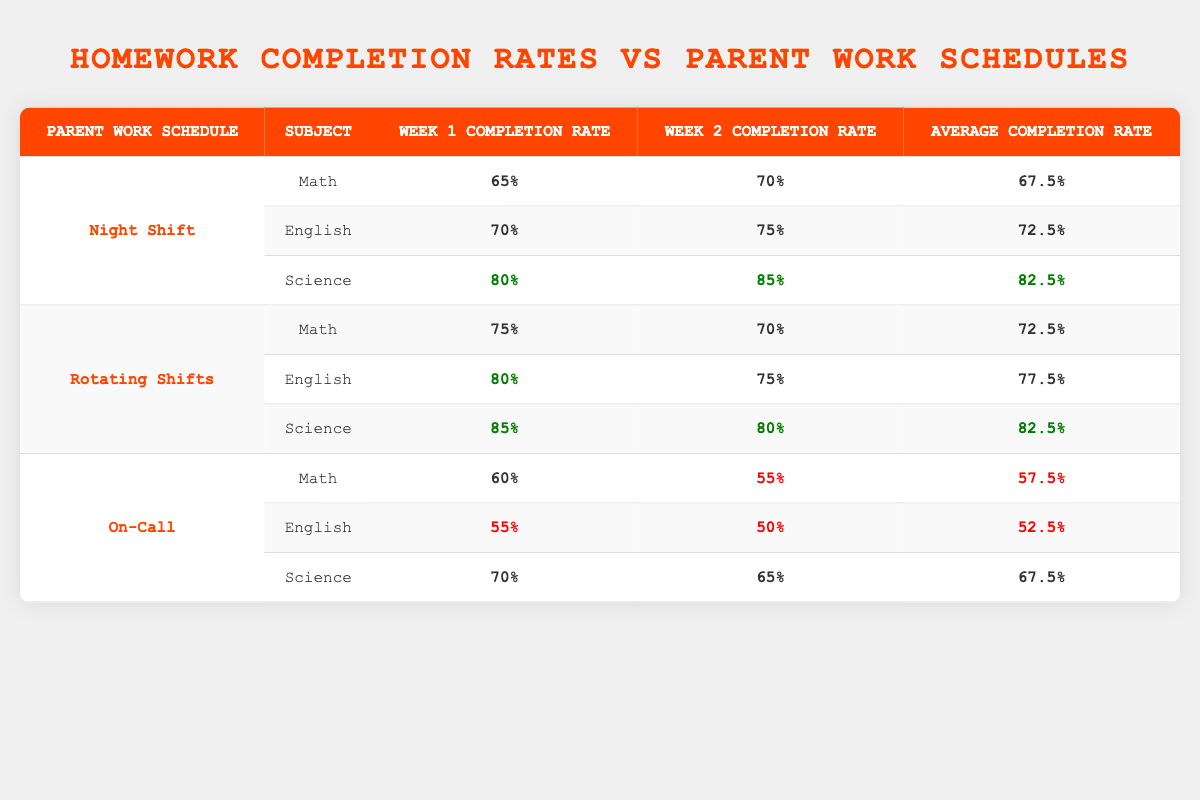What is the homework completion rate for Jake in Science during Week 1? According to the table, Jake's homework completion rate for Science in Week 1 is listed as 80%.
Answer: 80% What was the highest average homework completion rate among the three parent work schedules? The average completion rates are: Night Shift 72.5%, Rotating Shifts 77.5%, and On-Call 57.5%. The highest average is for Rotating Shifts at 77.5%.
Answer: 77.5% Did Tyler have a higher homework completion rate in Science during Week 2 compared to Week 1? In Week 1, Tyler's completion rate in Science is 70%, while in Week 2 it is 65%. Since 70% is greater than 65%, the answer is no.
Answer: No What is the average homework completion rate for subjects taught under Night Shift? For Night Shift, the averages must be calculated as follows: Math (67.5%) + English (72.5%) + Science (82.5%) = 222.5% total. Dividing by 3 subjects gives an average of 74.17%.
Answer: 74.17% Is it true that Emma had a higher completion rate in English during Week 1 than Jake did in English during the same week? In Week 1, Emma's rate in English is 80%, while Jake's in English is 70%. Since 80% is greater than 70%, the statement is true.
Answer: Yes What is the difference between the homework completion rates for Math and Science for Tyler in Week 1? Tyler's Math completion rate in Week 1 is 60%, and for Science, it is 70%. The difference is 70% - 60% = 10%.
Answer: 10% How much higher was Emma's average homework completion rate compared to Jake's for Week 2? Emma's average completion for Week 2: Math 70% + English 75% + Science 80% = 225%, dividing gives an average of 75%. Jake's average for Week 2: Math 70% + English 75% + Science 85% = 230%, giving an average of 76.67%. The difference is 76.67% - 75% = 1.67%.
Answer: 1.67% Which student had the lowest overall homework completion rate? Evaluating each student's average completion rates, Tyler has an average of 57.5%, which is lower than Jake's 72.5% and Emma's 77.5%. Therefore, Tyler has the lowest overall rate.
Answer: Tyler 